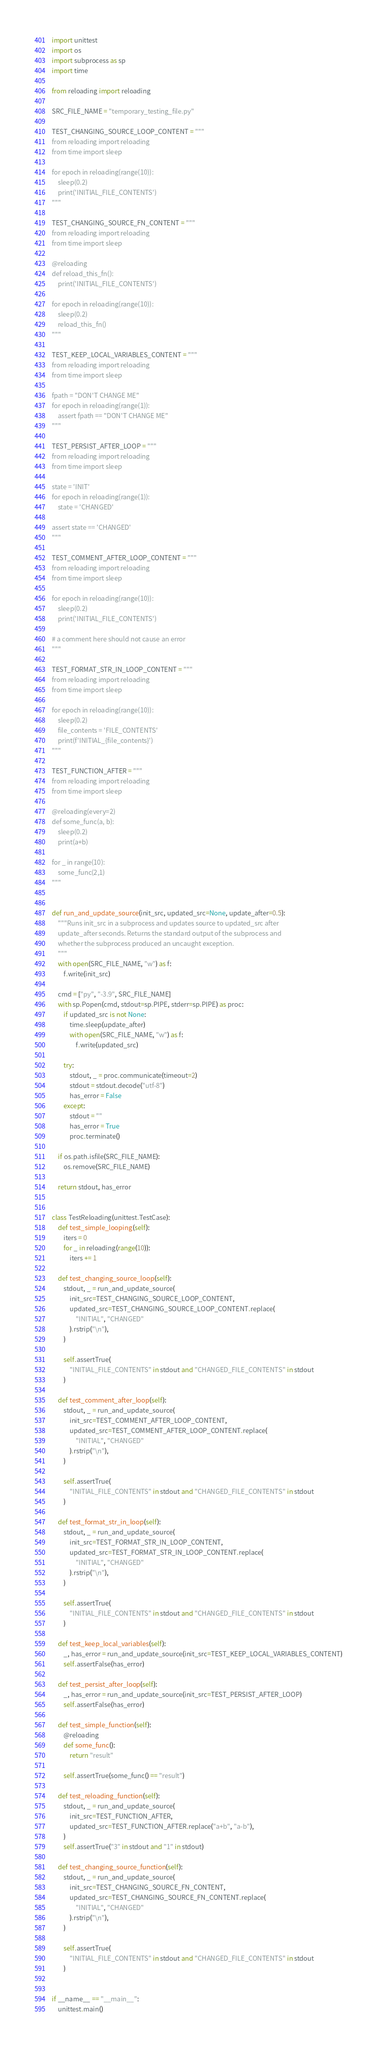Convert code to text. <code><loc_0><loc_0><loc_500><loc_500><_Python_>import unittest
import os
import subprocess as sp
import time

from reloading import reloading

SRC_FILE_NAME = "temporary_testing_file.py"

TEST_CHANGING_SOURCE_LOOP_CONTENT = """
from reloading import reloading
from time import sleep

for epoch in reloading(range(10)):
    sleep(0.2)
    print('INITIAL_FILE_CONTENTS')
"""

TEST_CHANGING_SOURCE_FN_CONTENT = """
from reloading import reloading
from time import sleep

@reloading
def reload_this_fn():
    print('INITIAL_FILE_CONTENTS')

for epoch in reloading(range(10)):
    sleep(0.2)
    reload_this_fn()
"""

TEST_KEEP_LOCAL_VARIABLES_CONTENT = """
from reloading import reloading
from time import sleep

fpath = "DON'T CHANGE ME"
for epoch in reloading(range(1)):
    assert fpath == "DON'T CHANGE ME"
"""

TEST_PERSIST_AFTER_LOOP = """
from reloading import reloading
from time import sleep

state = 'INIT'
for epoch in reloading(range(1)):
    state = 'CHANGED'

assert state == 'CHANGED'
"""

TEST_COMMENT_AFTER_LOOP_CONTENT = """
from reloading import reloading
from time import sleep

for epoch in reloading(range(10)):
    sleep(0.2)
    print('INITIAL_FILE_CONTENTS')

# a comment here should not cause an error
"""

TEST_FORMAT_STR_IN_LOOP_CONTENT = """
from reloading import reloading
from time import sleep

for epoch in reloading(range(10)):
    sleep(0.2)
    file_contents = 'FILE_CONTENTS'
    print(f'INITIAL_{file_contents}')
"""

TEST_FUNCTION_AFTER = """
from reloading import reloading
from time import sleep

@reloading(every=2)
def some_func(a, b):
    sleep(0.2)
    print(a+b)

for _ in range(10):
    some_func(2,1)
"""


def run_and_update_source(init_src, updated_src=None, update_after=0.5):
    """Runs init_src in a subprocess and updates source to updated_src after
    update_after seconds. Returns the standard output of the subprocess and
    whether the subprocess produced an uncaught exception.
    """
    with open(SRC_FILE_NAME, "w") as f:
        f.write(init_src)

    cmd = ["py", "-3.9", SRC_FILE_NAME]
    with sp.Popen(cmd, stdout=sp.PIPE, stderr=sp.PIPE) as proc:
        if updated_src is not None:
            time.sleep(update_after)
            with open(SRC_FILE_NAME, "w") as f:
                f.write(updated_src)

        try:
            stdout, _ = proc.communicate(timeout=2)
            stdout = stdout.decode("utf-8")
            has_error = False
        except:
            stdout = ""
            has_error = True
            proc.terminate()

    if os.path.isfile(SRC_FILE_NAME):
        os.remove(SRC_FILE_NAME)

    return stdout, has_error


class TestReloading(unittest.TestCase):
    def test_simple_looping(self):
        iters = 0
        for _ in reloading(range(10)):
            iters += 1

    def test_changing_source_loop(self):
        stdout, _ = run_and_update_source(
            init_src=TEST_CHANGING_SOURCE_LOOP_CONTENT,
            updated_src=TEST_CHANGING_SOURCE_LOOP_CONTENT.replace(
                "INITIAL", "CHANGED"
            ).rstrip("\n"),
        )

        self.assertTrue(
            "INITIAL_FILE_CONTENTS" in stdout and "CHANGED_FILE_CONTENTS" in stdout
        )

    def test_comment_after_loop(self):
        stdout, _ = run_and_update_source(
            init_src=TEST_COMMENT_AFTER_LOOP_CONTENT,
            updated_src=TEST_COMMENT_AFTER_LOOP_CONTENT.replace(
                "INITIAL", "CHANGED"
            ).rstrip("\n"),
        )

        self.assertTrue(
            "INITIAL_FILE_CONTENTS" in stdout and "CHANGED_FILE_CONTENTS" in stdout
        )

    def test_format_str_in_loop(self):
        stdout, _ = run_and_update_source(
            init_src=TEST_FORMAT_STR_IN_LOOP_CONTENT,
            updated_src=TEST_FORMAT_STR_IN_LOOP_CONTENT.replace(
                "INITIAL", "CHANGED"
            ).rstrip("\n"),
        )

        self.assertTrue(
            "INITIAL_FILE_CONTENTS" in stdout and "CHANGED_FILE_CONTENTS" in stdout
        )

    def test_keep_local_variables(self):
        _, has_error = run_and_update_source(init_src=TEST_KEEP_LOCAL_VARIABLES_CONTENT)
        self.assertFalse(has_error)

    def test_persist_after_loop(self):
        _, has_error = run_and_update_source(init_src=TEST_PERSIST_AFTER_LOOP)
        self.assertFalse(has_error)

    def test_simple_function(self):
        @reloading
        def some_func():
            return "result"

        self.assertTrue(some_func() == "result")

    def test_reloading_function(self):
        stdout, _ = run_and_update_source(
            init_src=TEST_FUNCTION_AFTER,
            updated_src=TEST_FUNCTION_AFTER.replace("a+b", "a-b"),
        )
        self.assertTrue("3" in stdout and "1" in stdout)

    def test_changing_source_function(self):
        stdout, _ = run_and_update_source(
            init_src=TEST_CHANGING_SOURCE_FN_CONTENT,
            updated_src=TEST_CHANGING_SOURCE_FN_CONTENT.replace(
                "INITIAL", "CHANGED"
            ).rstrip("\n"),
        )

        self.assertTrue(
            "INITIAL_FILE_CONTENTS" in stdout and "CHANGED_FILE_CONTENTS" in stdout
        )


if __name__ == "__main__":
    unittest.main()
</code> 